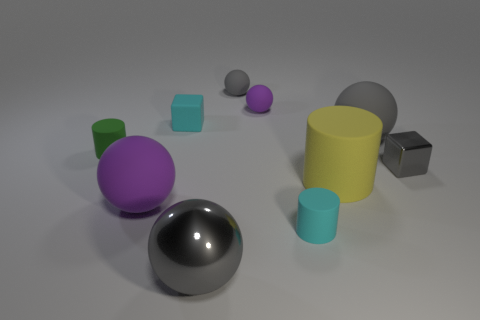Is there anything else that has the same size as the green cylinder?
Give a very brief answer. Yes. Is there a tiny green thing to the left of the tiny gray thing on the left side of the big rubber ball that is to the right of the yellow cylinder?
Offer a terse response. Yes. There is a block that is right of the large gray shiny ball; what is its material?
Your response must be concise. Metal. Is the size of the yellow rubber thing the same as the green cylinder?
Offer a terse response. No. There is a big rubber thing that is to the right of the cyan matte cube and in front of the green cylinder; what is its color?
Your answer should be compact. Yellow. What shape is the purple object that is the same material as the small purple sphere?
Offer a terse response. Sphere. How many balls are in front of the tiny green cylinder and to the right of the big metallic ball?
Make the answer very short. 0. There is a large gray metal thing; are there any purple balls to the left of it?
Provide a succinct answer. Yes. There is a tiny cyan matte object that is behind the green rubber object; is it the same shape as the purple matte thing on the left side of the tiny gray sphere?
Provide a short and direct response. No. How many things are small yellow matte balls or gray spheres that are behind the green cylinder?
Your answer should be compact. 2. 